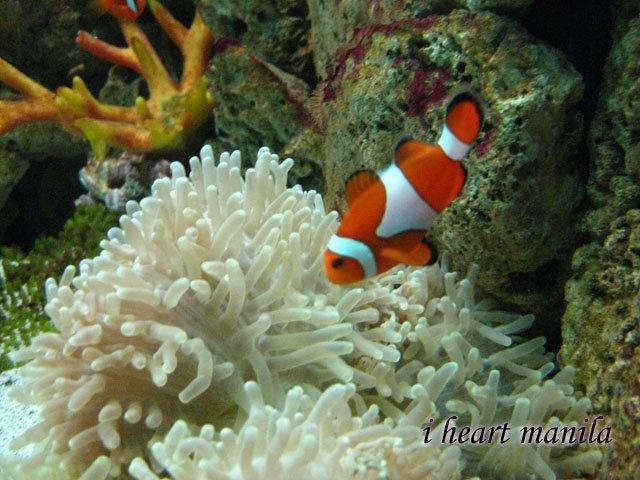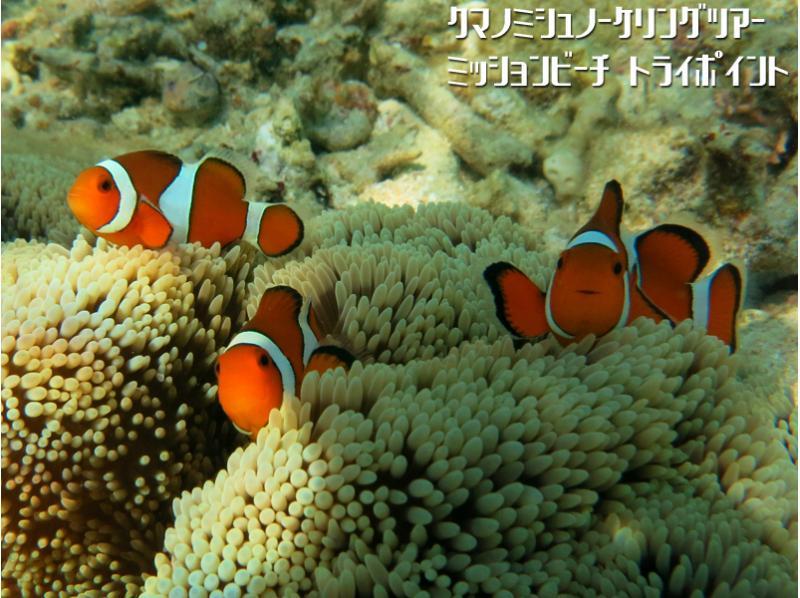The first image is the image on the left, the second image is the image on the right. Examine the images to the left and right. Is the description "In one of the images in each pair are two fish in anenome tentacles." accurate? Answer yes or no. No. 